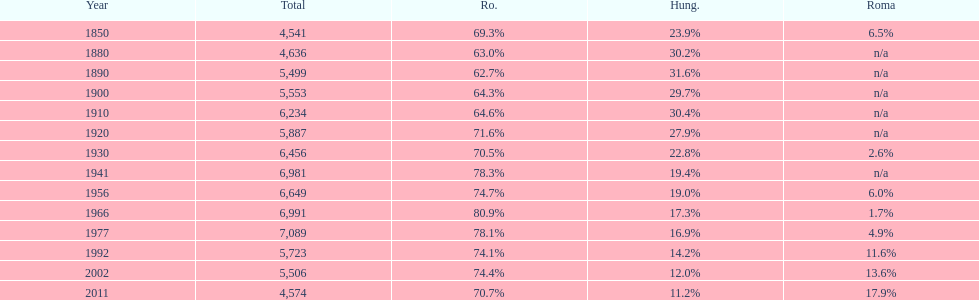Which year had a total of 6,981 and 19.4% hungarians? 1941. 